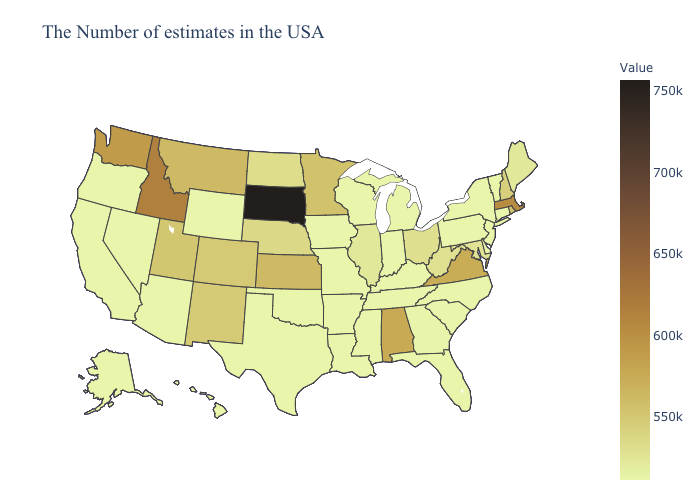Among the states that border Rhode Island , does Massachusetts have the lowest value?
Quick response, please. No. Which states have the highest value in the USA?
Write a very short answer. South Dakota. Among the states that border Maryland , which have the lowest value?
Give a very brief answer. Delaware, Pennsylvania. Which states have the lowest value in the West?
Short answer required. Wyoming, Arizona, Nevada, California, Oregon, Alaska, Hawaii. Which states have the lowest value in the USA?
Concise answer only. Vermont, Connecticut, New York, New Jersey, Delaware, Pennsylvania, North Carolina, South Carolina, Florida, Michigan, Kentucky, Indiana, Tennessee, Wisconsin, Mississippi, Louisiana, Missouri, Arkansas, Iowa, Oklahoma, Texas, Wyoming, Arizona, Nevada, California, Oregon, Alaska, Hawaii. Is the legend a continuous bar?
Be succinct. Yes. 